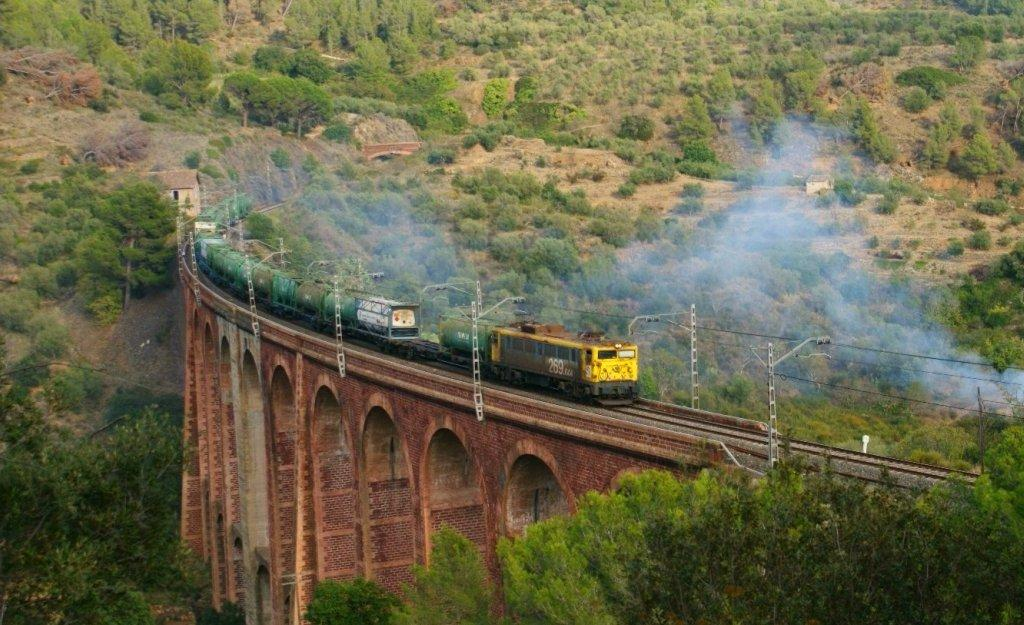What is the main subject of the image? There is a locomotive in the image. Where is the locomotive situated? The locomotive is on a railway track. How is the railway track constructed? The railway track is constructed over a bridge. What type of natural features can be seen in the image? Hills, trees, and bushes are visible in the image. What type of soda is being served in the image? There is no soda present in the image; it features a locomotive on a railway track over a bridge. What kind of pest can be seen crawling on the locomotive in the image? There are no pests visible on the locomotive in the image. 